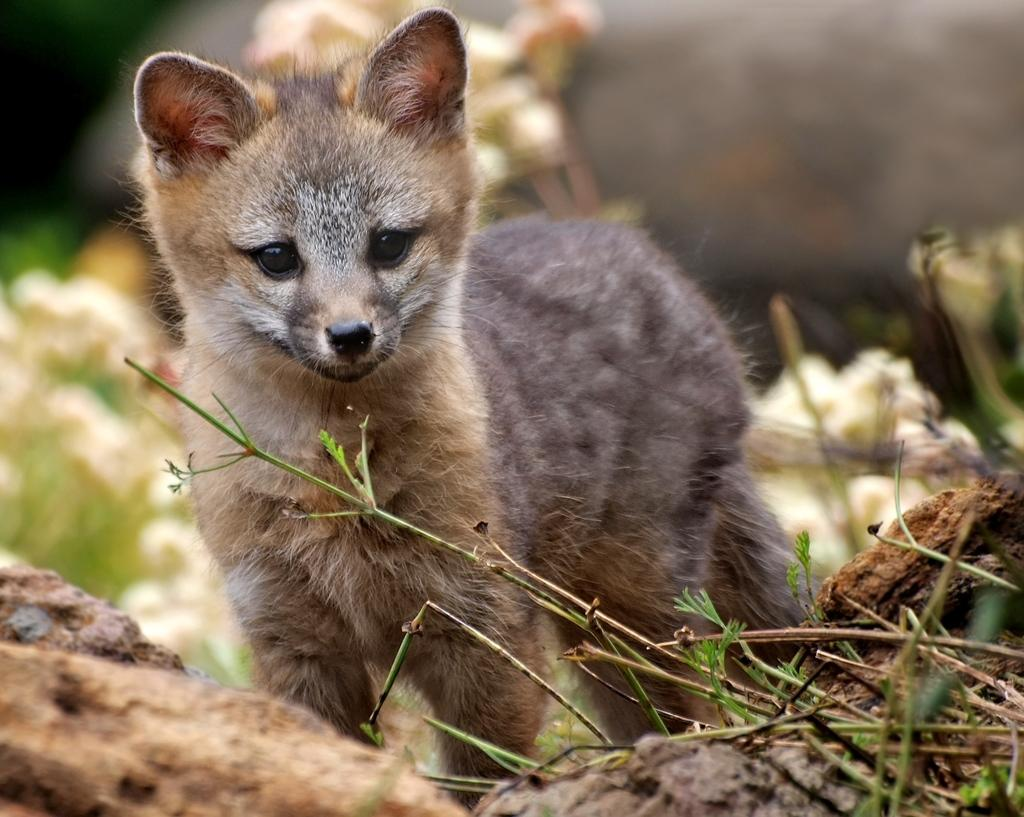What type of animal is in the image? There is a baby gray fox in the image. What can be seen at the right bottom of the image? There are branches of a plant at the right bottom of the image. How would you describe the background of the image? The background of the image is blurry. What achievements has the machine in the image accomplished? There is no machine present in the image, so it is not possible to discuss any achievements. 